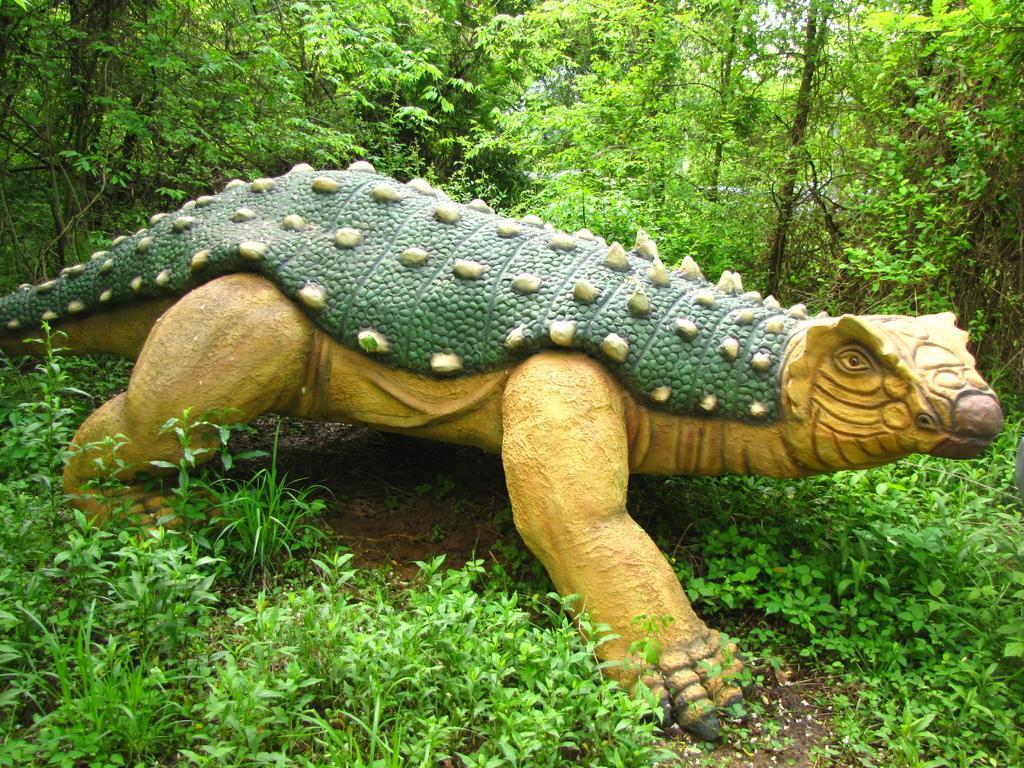Describe this image in one or two sentences. In this picture I can see there is a statue of a dinosaur and there are few plants and soil on the floor. In the backdrop there are trees. 